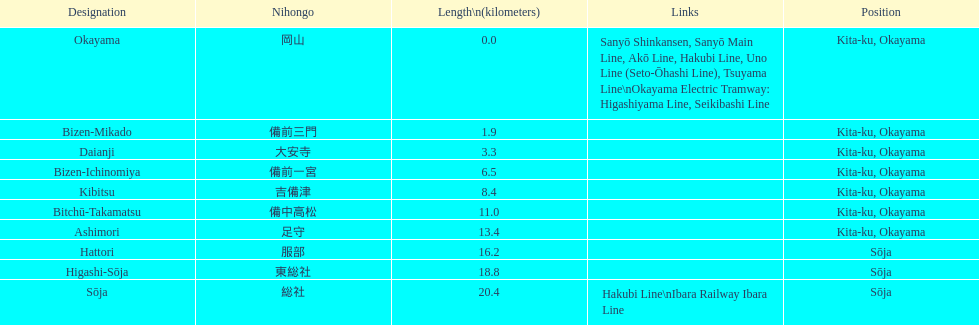Write the full table. {'header': ['Designation', 'Nihongo', 'Length\\n(kilometers)', 'Links', 'Position'], 'rows': [['Okayama', '岡山', '0.0', 'Sanyō Shinkansen, Sanyō Main Line, Akō Line, Hakubi Line, Uno Line (Seto-Ōhashi Line), Tsuyama Line\\nOkayama Electric Tramway: Higashiyama Line, Seikibashi Line', 'Kita-ku, Okayama'], ['Bizen-Mikado', '備前三門', '1.9', '', 'Kita-ku, Okayama'], ['Daianji', '大安寺', '3.3', '', 'Kita-ku, Okayama'], ['Bizen-Ichinomiya', '備前一宮', '6.5', '', 'Kita-ku, Okayama'], ['Kibitsu', '吉備津', '8.4', '', 'Kita-ku, Okayama'], ['Bitchū-Takamatsu', '備中高松', '11.0', '', 'Kita-ku, Okayama'], ['Ashimori', '足守', '13.4', '', 'Kita-ku, Okayama'], ['Hattori', '服部', '16.2', '', 'Sōja'], ['Higashi-Sōja', '東総社', '18.8', '', 'Sōja'], ['Sōja', '総社', '20.4', 'Hakubi Line\\nIbara Railway Ibara Line', 'Sōja']]} Which has a distance of more than 1 kilometer but less than 2 kilometers? Bizen-Mikado. 